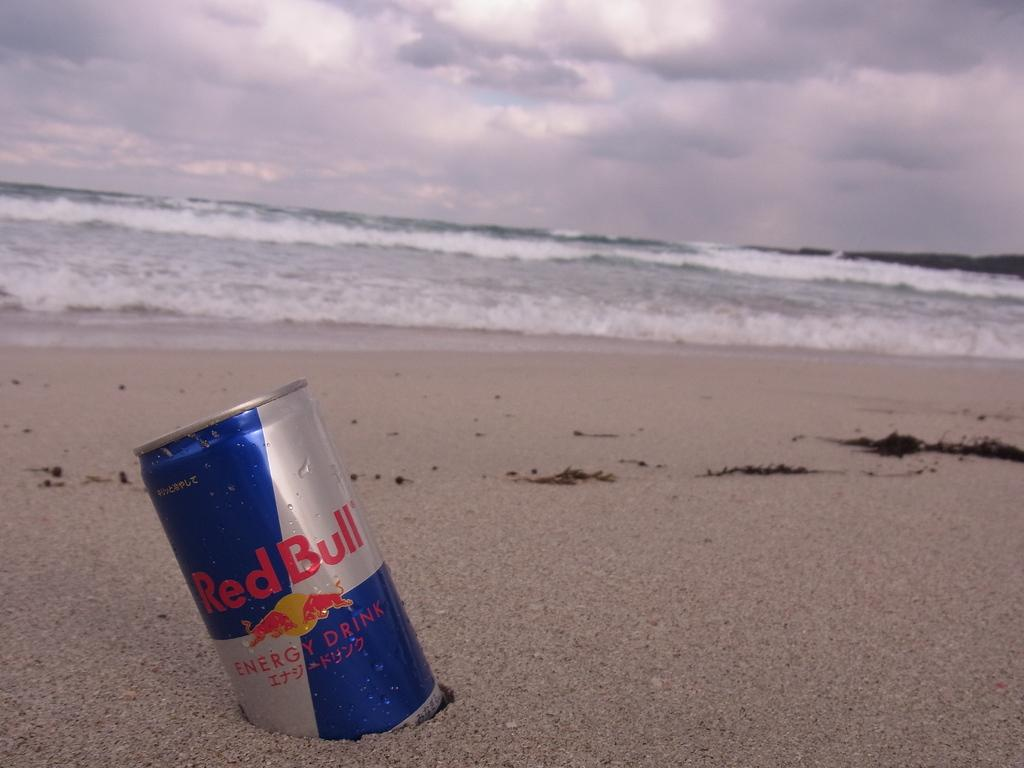<image>
Present a compact description of the photo's key features. A can of Red Bull sits in the wet sand at the beach. 